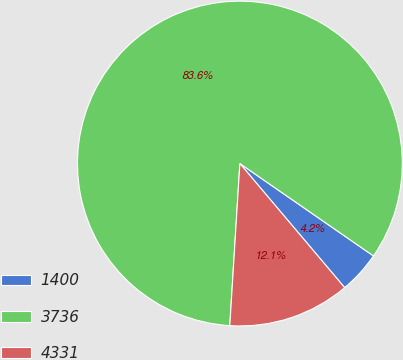Convert chart. <chart><loc_0><loc_0><loc_500><loc_500><pie_chart><fcel>1400<fcel>3736<fcel>4331<nl><fcel>4.21%<fcel>83.64%<fcel>12.15%<nl></chart> 